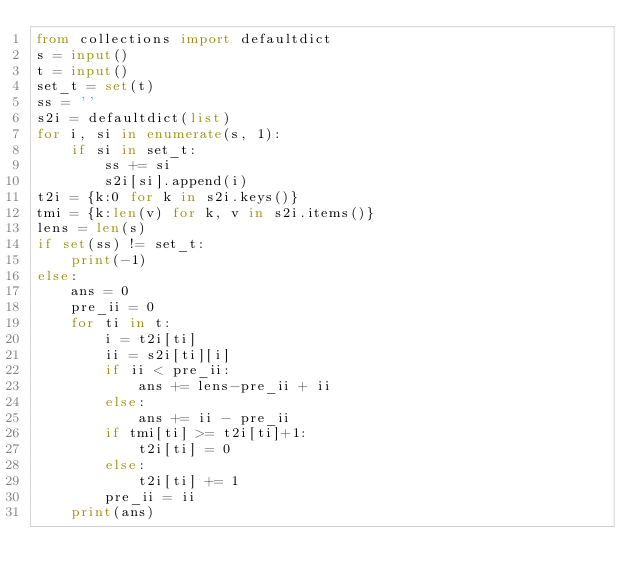Convert code to text. <code><loc_0><loc_0><loc_500><loc_500><_Python_>from collections import defaultdict
s = input()
t = input()
set_t = set(t)
ss = ''
s2i = defaultdict(list)
for i, si in enumerate(s, 1):
    if si in set_t:
        ss += si
        s2i[si].append(i)
t2i = {k:0 for k in s2i.keys()}
tmi = {k:len(v) for k, v in s2i.items()}
lens = len(s)
if set(ss) != set_t:
    print(-1)
else:
    ans = 0
    pre_ii = 0
    for ti in t:
        i = t2i[ti]
        ii = s2i[ti][i]
        if ii < pre_ii:
            ans += lens-pre_ii + ii
        else:
            ans += ii - pre_ii
        if tmi[ti] >= t2i[ti]+1:
            t2i[ti] = 0
        else:
            t2i[ti] += 1
        pre_ii = ii
    print(ans)
        
</code> 